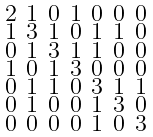<formula> <loc_0><loc_0><loc_500><loc_500>\begin{smallmatrix} 2 & 1 & 0 & 1 & 0 & 0 & 0 \\ 1 & 3 & 1 & 0 & 1 & 1 & 0 \\ 0 & 1 & 3 & 1 & 1 & 0 & 0 \\ 1 & 0 & 1 & 3 & 0 & 0 & 0 \\ 0 & 1 & 1 & 0 & 3 & 1 & 1 \\ 0 & 1 & 0 & 0 & 1 & 3 & 0 \\ 0 & 0 & 0 & 0 & 1 & 0 & 3 \end{smallmatrix}</formula> 